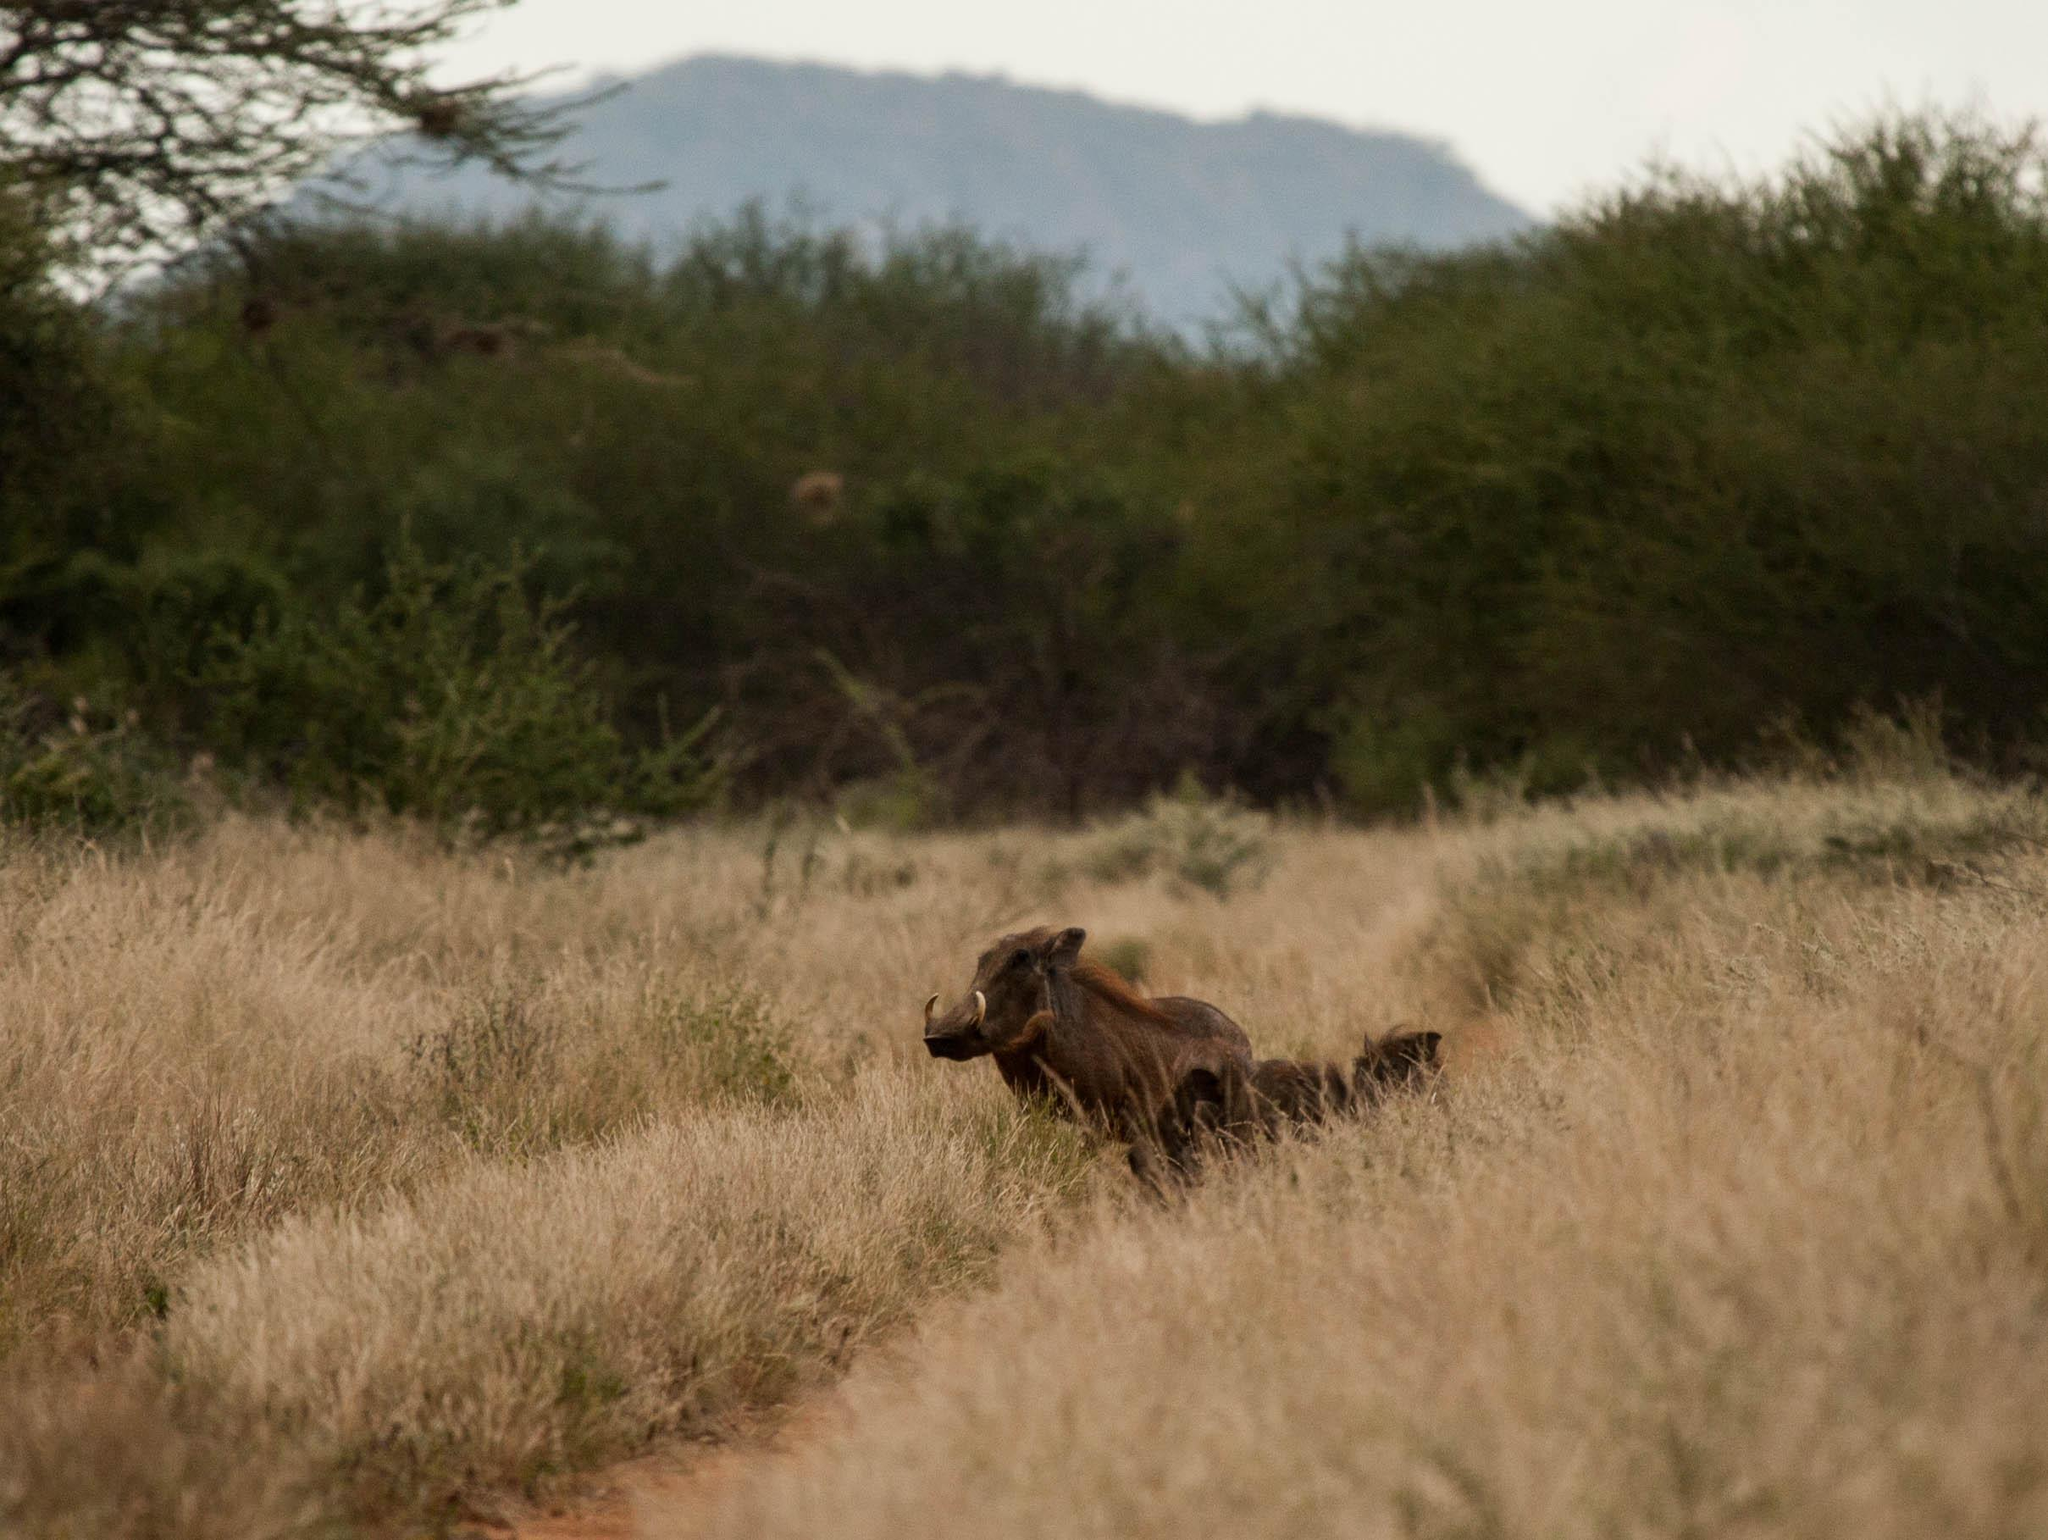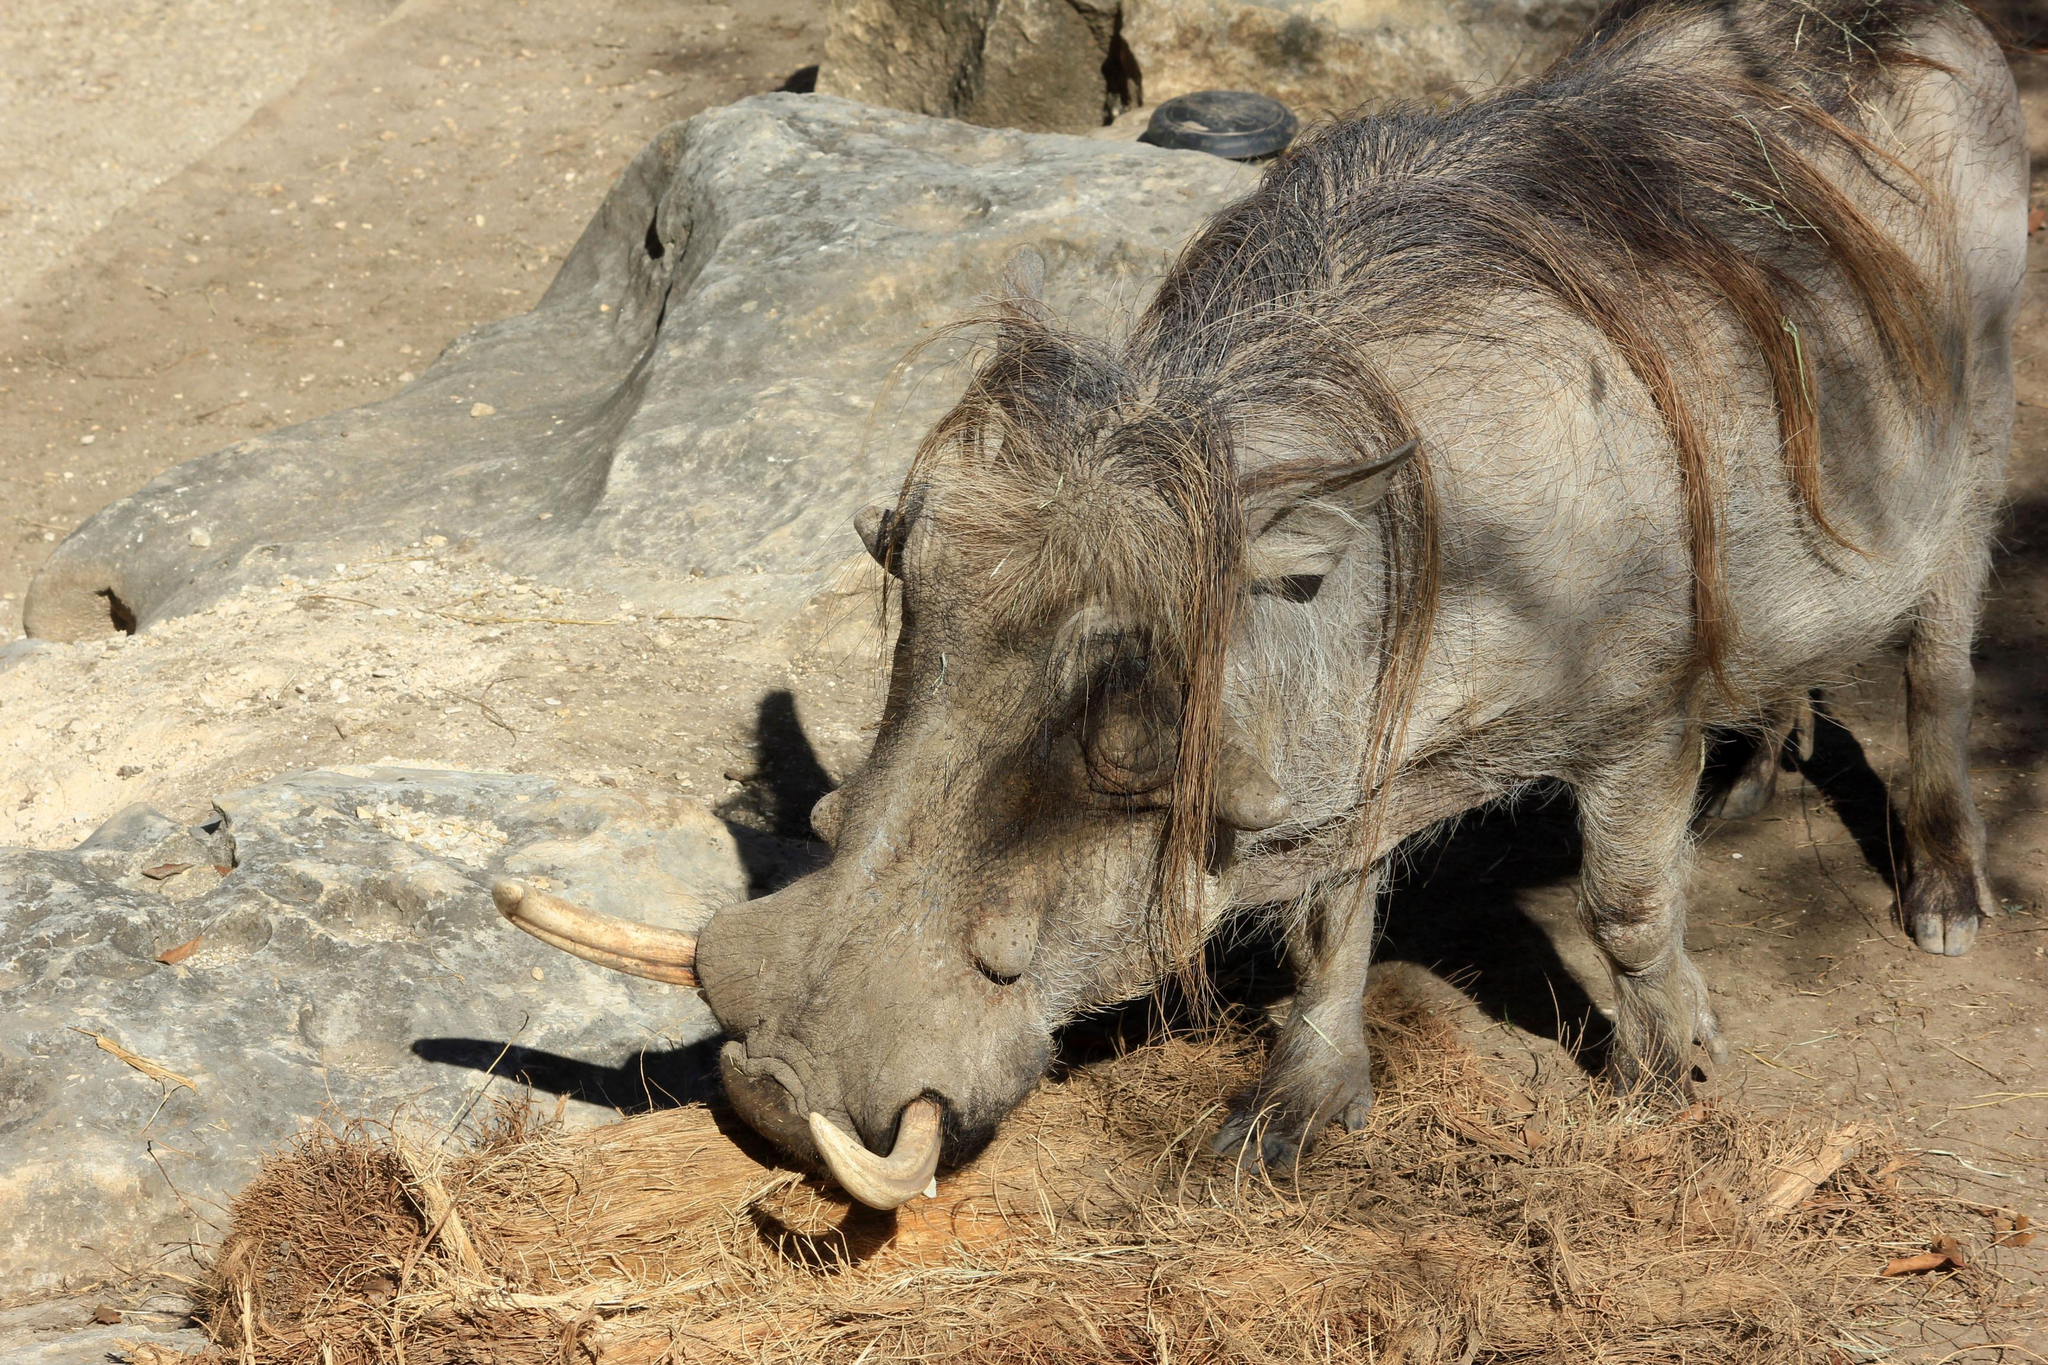The first image is the image on the left, the second image is the image on the right. Examine the images to the left and right. Is the description "There at least one lone animal that has large tusks." accurate? Answer yes or no. Yes. The first image is the image on the left, the second image is the image on the right. Evaluate the accuracy of this statement regarding the images: "One of the images has only one wart hog with two tusks.". Is it true? Answer yes or no. Yes. 